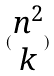Convert formula to latex. <formula><loc_0><loc_0><loc_500><loc_500>( \begin{matrix} n ^ { 2 } \\ k \end{matrix} )</formula> 